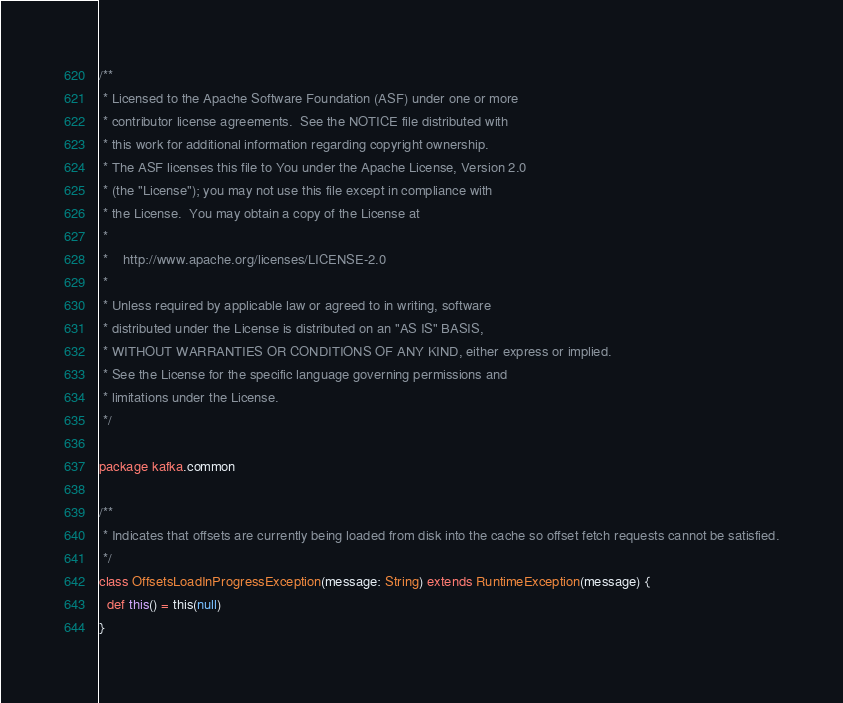Convert code to text. <code><loc_0><loc_0><loc_500><loc_500><_Scala_>/**
 * Licensed to the Apache Software Foundation (ASF) under one or more
 * contributor license agreements.  See the NOTICE file distributed with
 * this work for additional information regarding copyright ownership.
 * The ASF licenses this file to You under the Apache License, Version 2.0
 * (the "License"); you may not use this file except in compliance with
 * the License.  You may obtain a copy of the License at
 *
 *    http://www.apache.org/licenses/LICENSE-2.0
 *
 * Unless required by applicable law or agreed to in writing, software
 * distributed under the License is distributed on an "AS IS" BASIS,
 * WITHOUT WARRANTIES OR CONDITIONS OF ANY KIND, either express or implied.
 * See the License for the specific language governing permissions and
 * limitations under the License.
 */

package kafka.common

/**
 * Indicates that offsets are currently being loaded from disk into the cache so offset fetch requests cannot be satisfied.
 */
class OffsetsLoadInProgressException(message: String) extends RuntimeException(message) {
  def this() = this(null)
}

</code> 